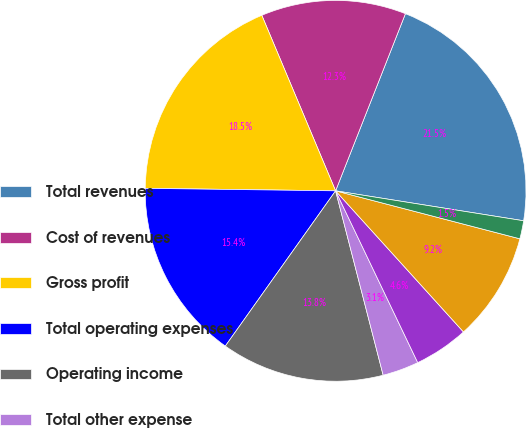Convert chart to OTSL. <chart><loc_0><loc_0><loc_500><loc_500><pie_chart><fcel>Total revenues<fcel>Cost of revenues<fcel>Gross profit<fcel>Total operating expenses<fcel>Operating income<fcel>Total other expense<fcel>Income tax expense<fcel>Net income<fcel>Net income applicable to<nl><fcel>21.54%<fcel>12.31%<fcel>18.46%<fcel>15.38%<fcel>13.85%<fcel>3.08%<fcel>4.62%<fcel>9.23%<fcel>1.54%<nl></chart> 